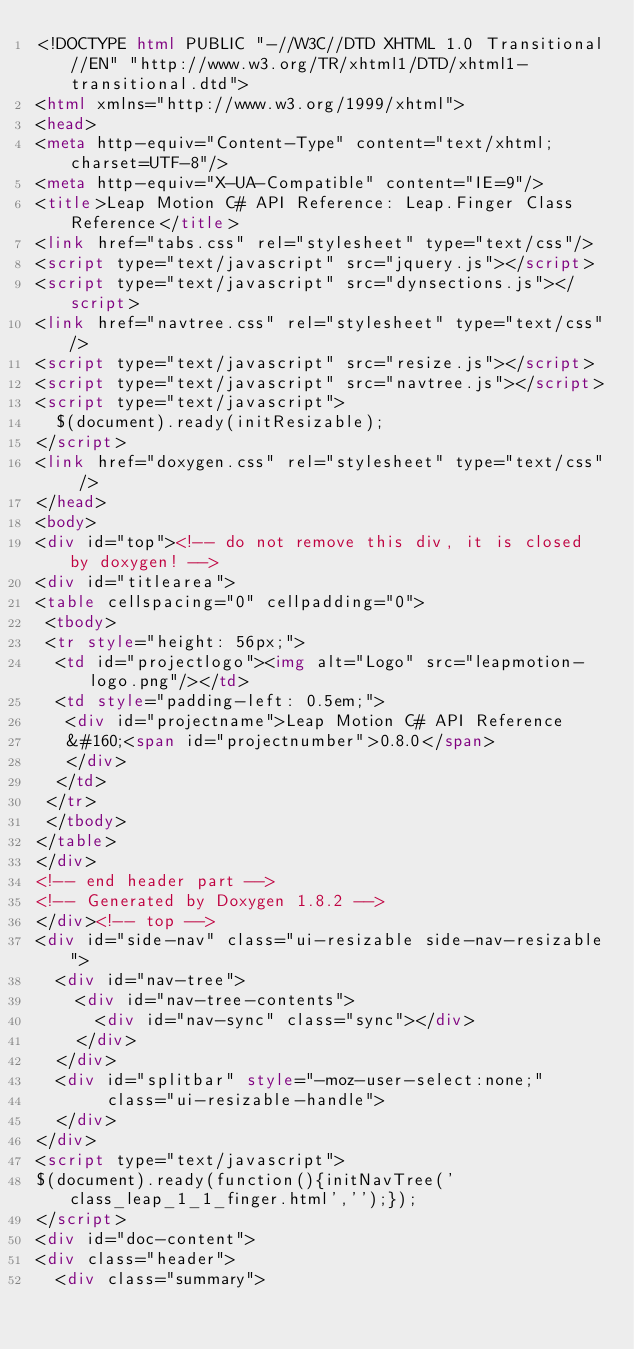Convert code to text. <code><loc_0><loc_0><loc_500><loc_500><_HTML_><!DOCTYPE html PUBLIC "-//W3C//DTD XHTML 1.0 Transitional//EN" "http://www.w3.org/TR/xhtml1/DTD/xhtml1-transitional.dtd">
<html xmlns="http://www.w3.org/1999/xhtml">
<head>
<meta http-equiv="Content-Type" content="text/xhtml;charset=UTF-8"/>
<meta http-equiv="X-UA-Compatible" content="IE=9"/>
<title>Leap Motion C# API Reference: Leap.Finger Class Reference</title>
<link href="tabs.css" rel="stylesheet" type="text/css"/>
<script type="text/javascript" src="jquery.js"></script>
<script type="text/javascript" src="dynsections.js"></script>
<link href="navtree.css" rel="stylesheet" type="text/css"/>
<script type="text/javascript" src="resize.js"></script>
<script type="text/javascript" src="navtree.js"></script>
<script type="text/javascript">
  $(document).ready(initResizable);
</script>
<link href="doxygen.css" rel="stylesheet" type="text/css" />
</head>
<body>
<div id="top"><!-- do not remove this div, it is closed by doxygen! -->
<div id="titlearea">
<table cellspacing="0" cellpadding="0">
 <tbody>
 <tr style="height: 56px;">
  <td id="projectlogo"><img alt="Logo" src="leapmotion-logo.png"/></td>
  <td style="padding-left: 0.5em;">
   <div id="projectname">Leap Motion C# API Reference
   &#160;<span id="projectnumber">0.8.0</span>
   </div>
  </td>
 </tr>
 </tbody>
</table>
</div>
<!-- end header part -->
<!-- Generated by Doxygen 1.8.2 -->
</div><!-- top -->
<div id="side-nav" class="ui-resizable side-nav-resizable">
  <div id="nav-tree">
    <div id="nav-tree-contents">
      <div id="nav-sync" class="sync"></div>
    </div>
  </div>
  <div id="splitbar" style="-moz-user-select:none;" 
       class="ui-resizable-handle">
  </div>
</div>
<script type="text/javascript">
$(document).ready(function(){initNavTree('class_leap_1_1_finger.html','');});
</script>
<div id="doc-content">
<div class="header">
  <div class="summary"></code> 